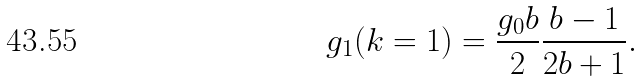Convert formula to latex. <formula><loc_0><loc_0><loc_500><loc_500>g _ { 1 } ( k = 1 ) = \frac { g _ { 0 } b } { 2 } \frac { b - 1 } { 2 b + 1 } .</formula> 